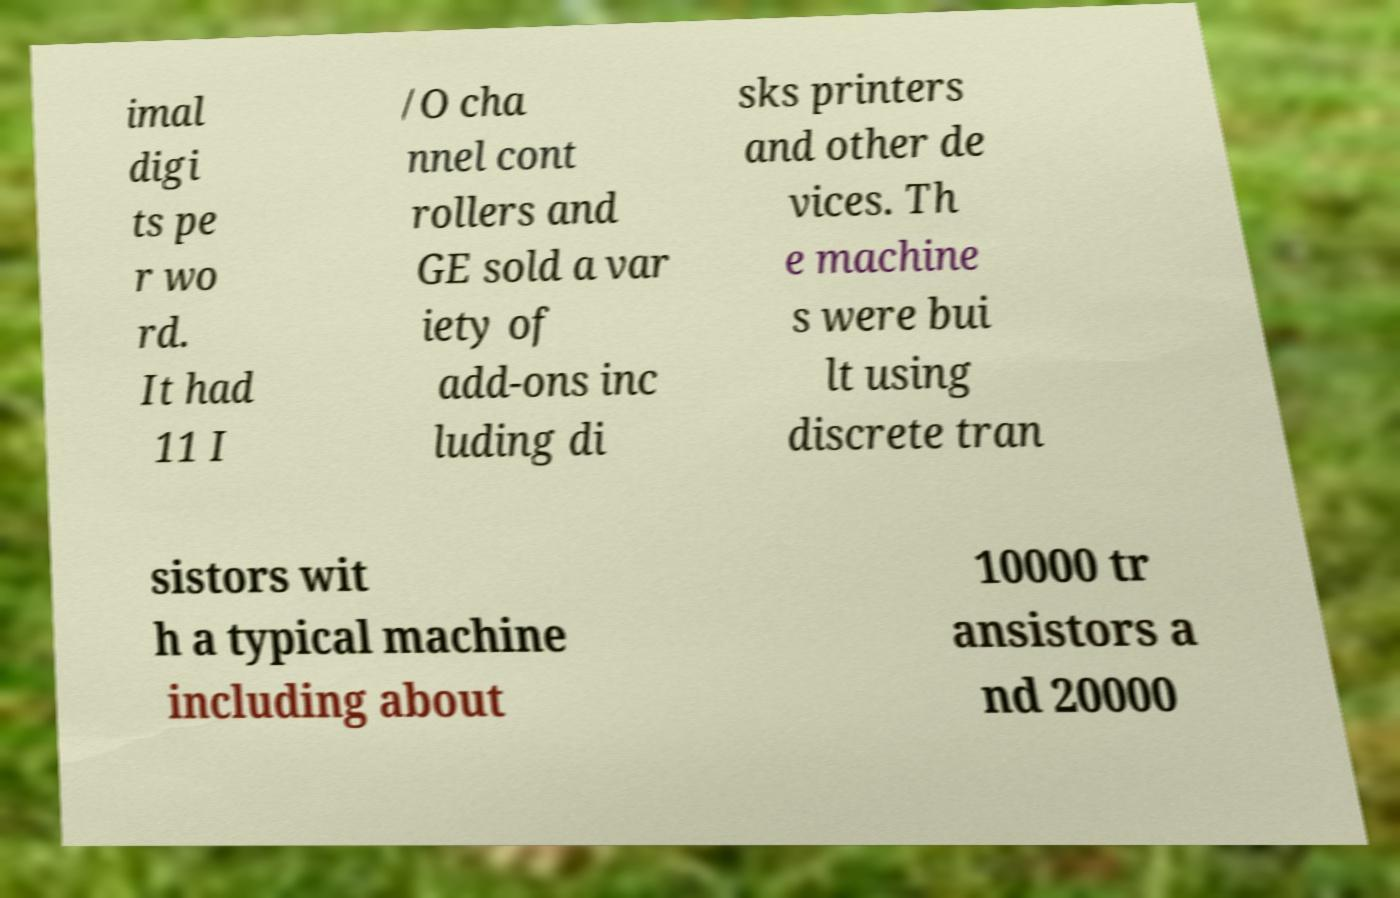Please identify and transcribe the text found in this image. imal digi ts pe r wo rd. It had 11 I /O cha nnel cont rollers and GE sold a var iety of add-ons inc luding di sks printers and other de vices. Th e machine s were bui lt using discrete tran sistors wit h a typical machine including about 10000 tr ansistors a nd 20000 